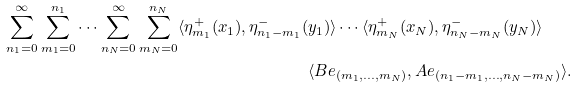Convert formula to latex. <formula><loc_0><loc_0><loc_500><loc_500>\sum _ { n _ { 1 } = 0 } ^ { \infty } \sum _ { m _ { 1 } = 0 } ^ { n _ { 1 } } \cdots \sum _ { n _ { N } = 0 } ^ { \infty } \sum _ { m _ { N } = 0 } ^ { n _ { N } } \langle \eta _ { m _ { 1 } } ^ { + } ( x _ { 1 } ) , \eta _ { n _ { 1 } - m _ { 1 } } ^ { - } ( & y _ { 1 } ) \rangle \cdots \langle \eta _ { m _ { N } } ^ { + } ( x _ { N } ) , \eta _ { n _ { N } - m _ { N } } ^ { - } ( y _ { N } ) \rangle \\ & \langle B e _ { ( m _ { 1 } , \dots , m _ { N } ) } , A e _ { ( n _ { 1 } - m _ { 1 } , \dots , n _ { N } - m _ { N } ) } \rangle .</formula> 